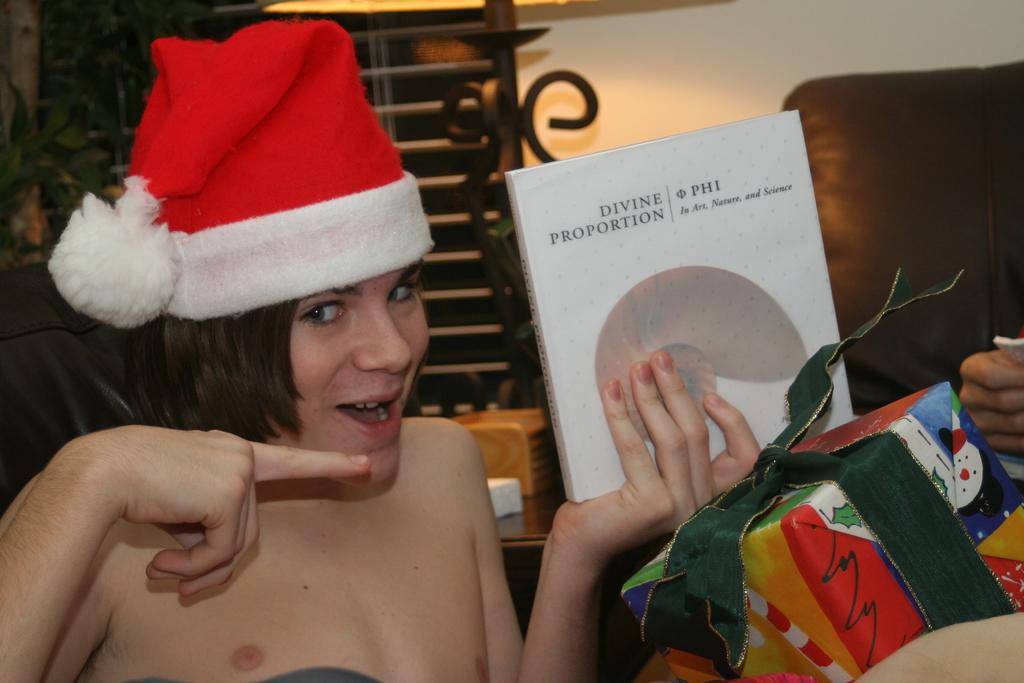What is the person in the image doing? The person is holding a book in their hands. Can you describe the person's attire? The person is wearing a hat. What can be seen on the right side of the image? There is a gift pack on the right side of the image. What is visible in the background of the image? There is a sofa, a wall, and a pole in the background of the image. What type of hole can be seen in the frame of the image? There is no hole or frame present in the image; it is a photograph or digital representation of a scene. 